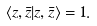Convert formula to latex. <formula><loc_0><loc_0><loc_500><loc_500>\langle z , \bar { z } | z , \bar { z } \rangle = 1 .</formula> 